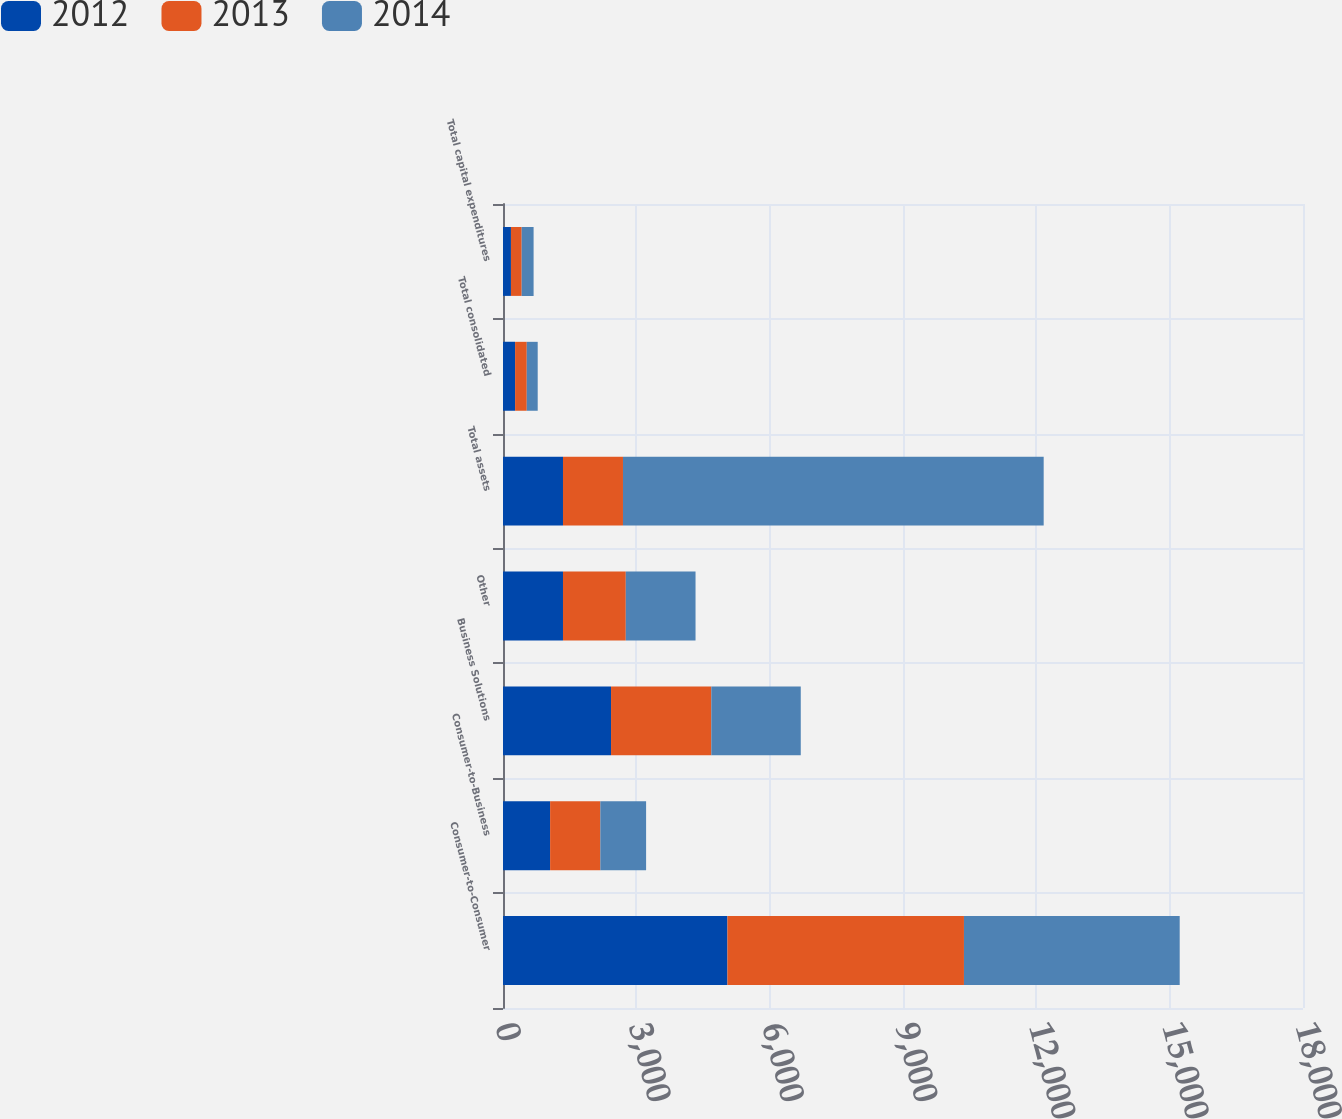Convert chart. <chart><loc_0><loc_0><loc_500><loc_500><stacked_bar_chart><ecel><fcel>Consumer-to-Consumer<fcel>Consumer-to-Business<fcel>Business Solutions<fcel>Other<fcel>Total assets<fcel>Total consolidated<fcel>Total capital expenditures<nl><fcel>2012<fcel>5049.7<fcel>1060.2<fcel>2430.7<fcel>1349.8<fcel>1349.8<fcel>271.9<fcel>179<nl><fcel>2013<fcel>5321.9<fcel>1129.9<fcel>2256.4<fcel>1413.1<fcel>1349.8<fcel>262.8<fcel>241.3<nl><fcel>2014<fcel>4854.2<fcel>1029.6<fcel>2012.6<fcel>1569.3<fcel>9465.7<fcel>246.1<fcel>268.2<nl></chart> 